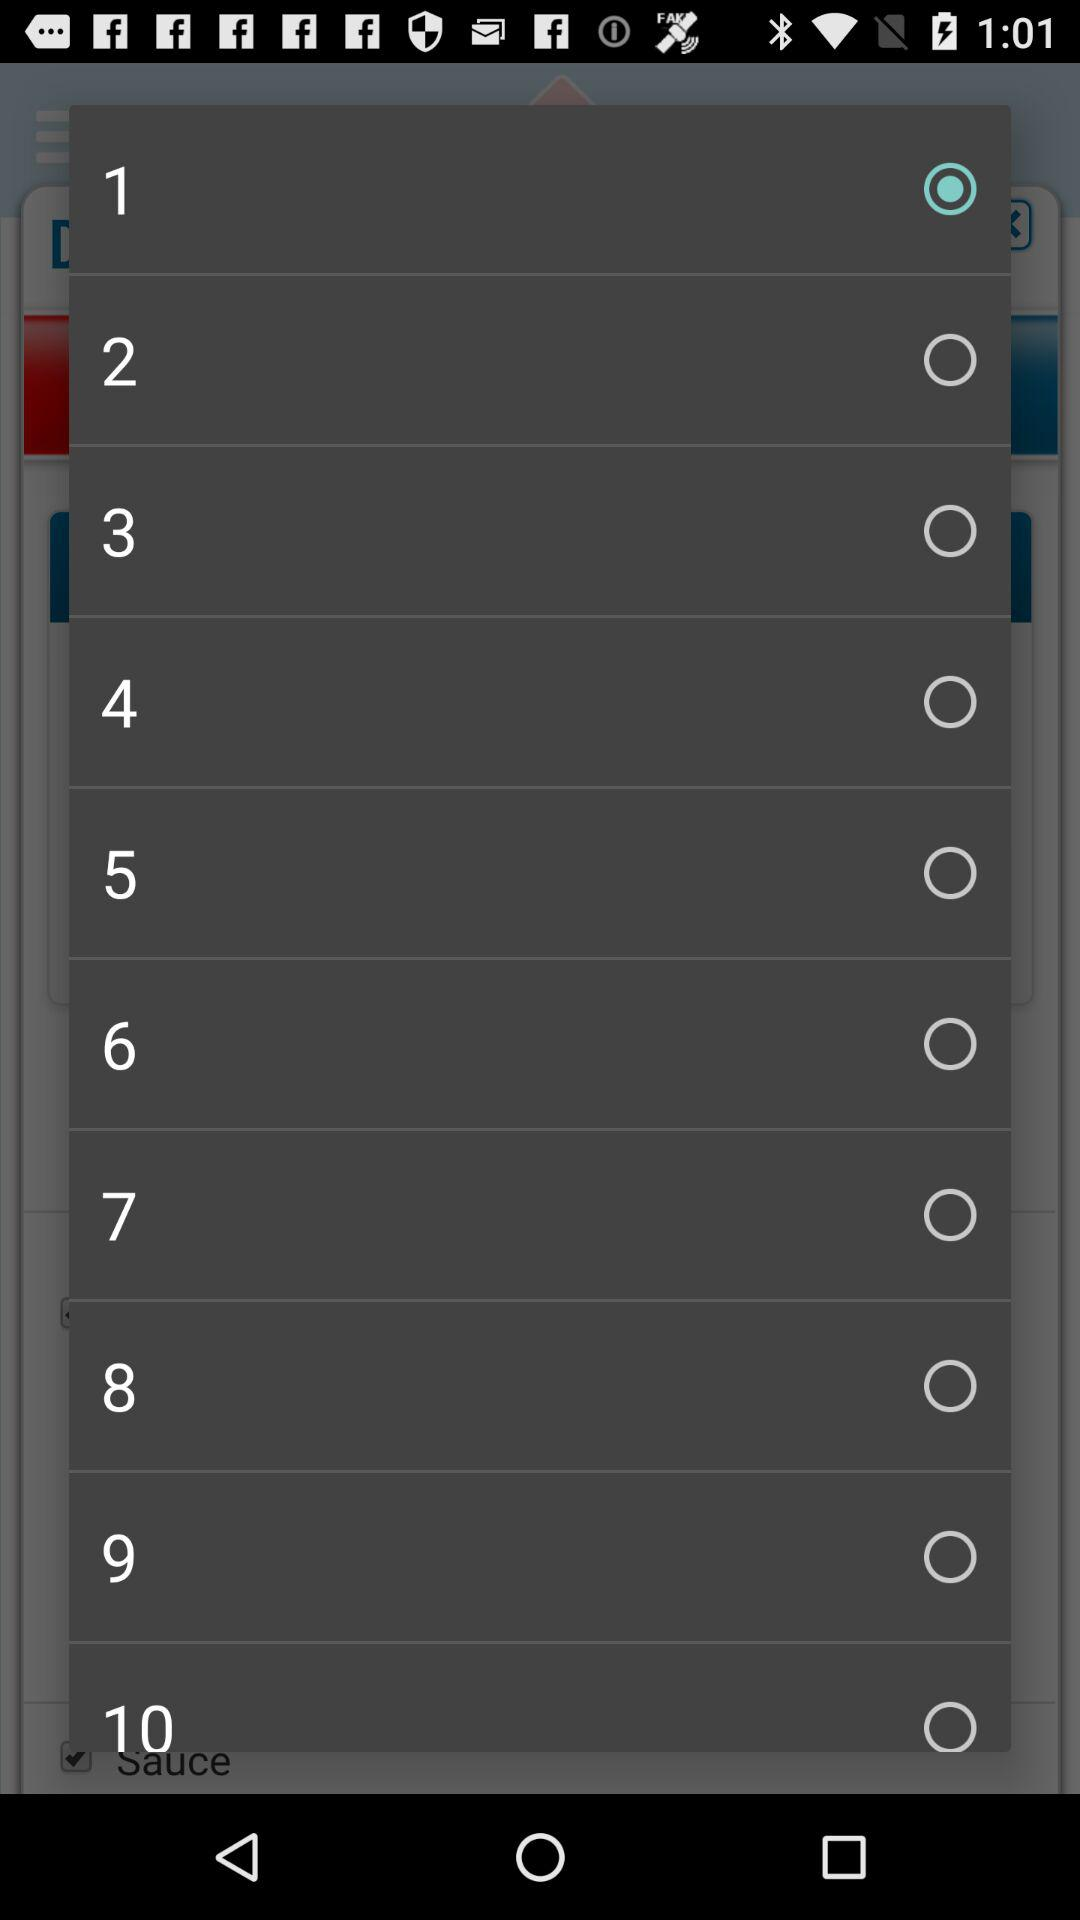Which is the selected radio button? The selected radio button is "1". 